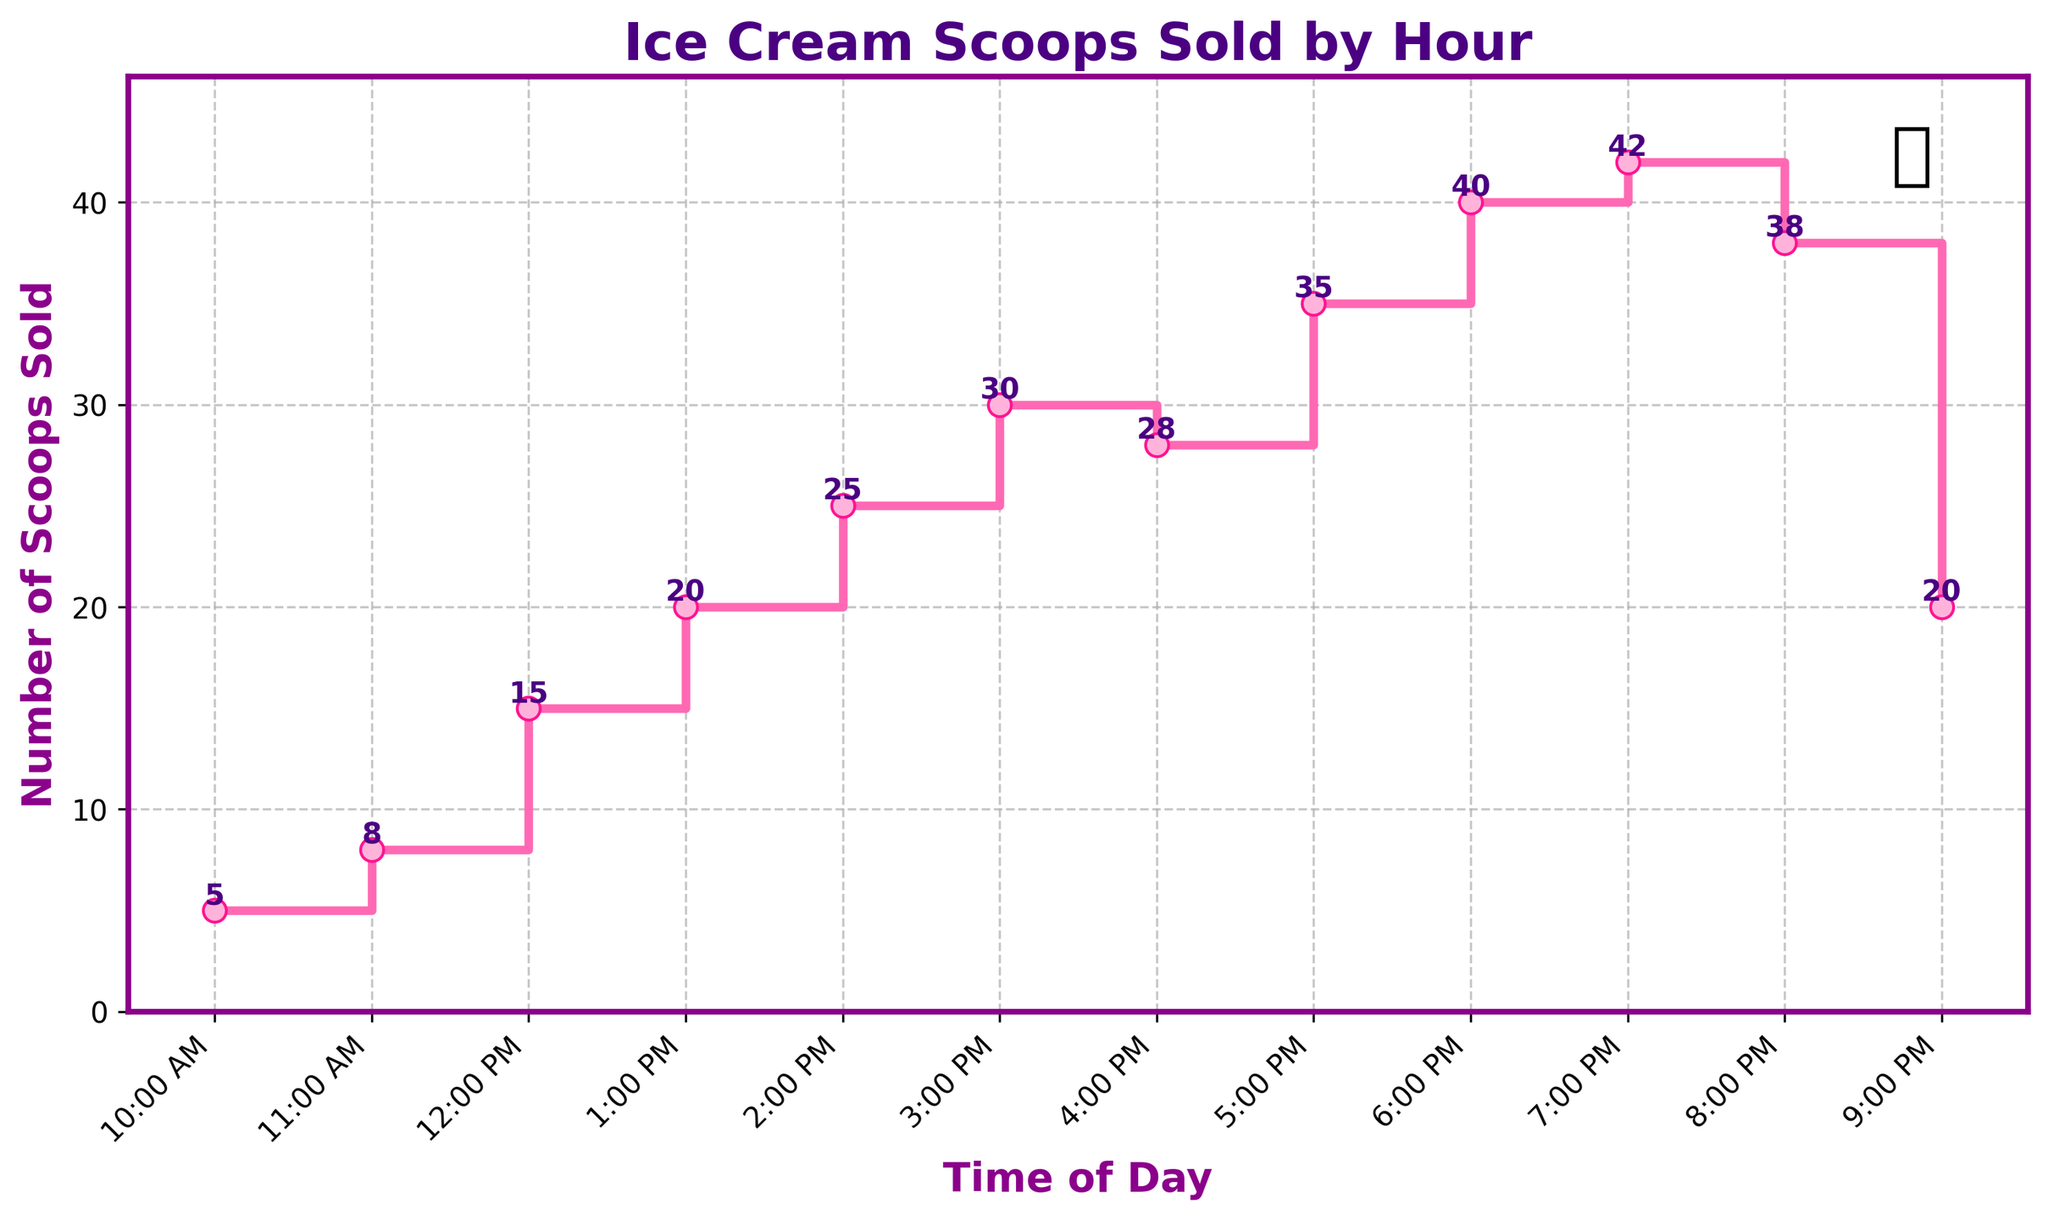What is the title of the plot? The title of the plot is often displayed on top of the figure. In this case, it reads "Ice Cream Scoops Sold by Hour".
Answer: Ice Cream Scoops Sold by Hour How many ice cream scoops were sold at 3:00 PM? To find the number of scoops sold at a particular hour, locate the hour on the x-axis and read the corresponding value on the y-axis. At 3:00 PM, the plot indicates 30 scoops were sold.
Answer: 30 During which hour were the most ice cream scoops sold? To determine the hour with the highest number of scoops sold, look for the highest point on the y-axis and trace it to the x-axis. The peak value is 42 scoops, occurring at 7:00 PM.
Answer: 7:00 PM What is the difference in the number of scoops sold between 10:00 AM and 6:00 PM? Find the number of scoops sold at both 10:00 AM (5 scoops) and 6:00 PM (40 scoops). Calculate the difference: 40 - 5 = 35.
Answer: 35 Between which consecutive hours did the number of scoops sold decrease the most? Examine the segments of the plot where the line goes downward and identify the greatest drop. The biggest decrease is from 8:00 PM (38 scoops) to 9:00 PM (20 scoops), resulting in a decrease of 18 scoops.
Answer: 8:00 PM to 9:00 PM What was the average number of scoops sold between 12:00 PM and 4:00 PM? Sum the scoops sold from 12:00 PM (15), 1:00 PM (20), 2:00 PM (25), 3:00 PM (30), and 4:00 PM (28). The sum is 118. Divide by the number of hours (5): 118/5 = 23.6.
Answer: 23.6 How many times did the sales reach 30 scoops or more in an hour? Identify and count the hours where the y-values are 30 or more. These hours are 3:00 PM (30), 5:00 PM (35), 6:00 PM (40), 7:00 PM (42), and 8:00 PM (38). There are 5 such instances.
Answer: 5 How many total scoops were sold throughout the day? Add up all the scoops sold at each hour: 5 + 8 + 15 + 20 + 25 + 30 + 28 + 35 + 40 + 42 + 38 + 20 = 306.
Answer: 306 Which hour saw the least amount of ice cream sales? Locate the lowest point on the y-axis and identify the corresponding x-axis value. The lowest value, 5 scoops, occurs at 10:00 AM.
Answer: 10:00 AM What is the general trend in ice cream sales throughout the day? Observe the slope of the plot from the start to the end. Initially, the number of scoops sold increases steadily until it peaks at 7:00 PM. After 7:00 PM, it sharply decreases.
Answer: Increase, then decrease 